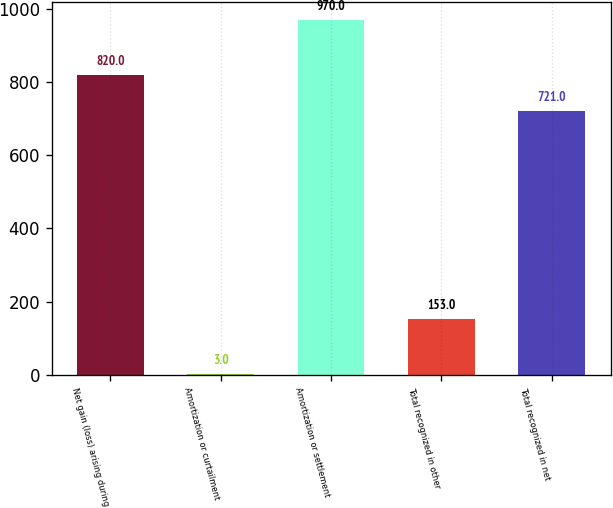Convert chart. <chart><loc_0><loc_0><loc_500><loc_500><bar_chart><fcel>Net gain (loss) arising during<fcel>Amortization or curtailment<fcel>Amortization or settlement<fcel>Total recognized in other<fcel>Total recognized in net<nl><fcel>820<fcel>3<fcel>970<fcel>153<fcel>721<nl></chart> 